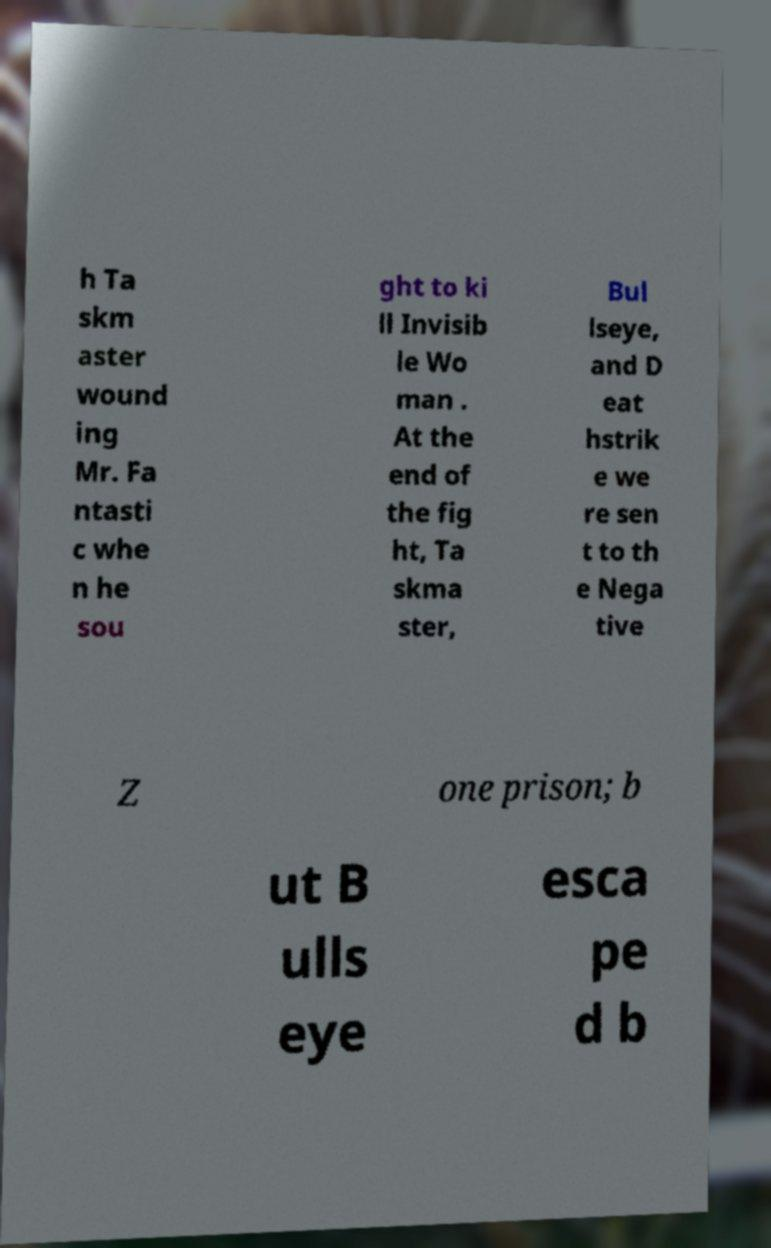What messages or text are displayed in this image? I need them in a readable, typed format. h Ta skm aster wound ing Mr. Fa ntasti c whe n he sou ght to ki ll Invisib le Wo man . At the end of the fig ht, Ta skma ster, Bul lseye, and D eat hstrik e we re sen t to th e Nega tive Z one prison; b ut B ulls eye esca pe d b 